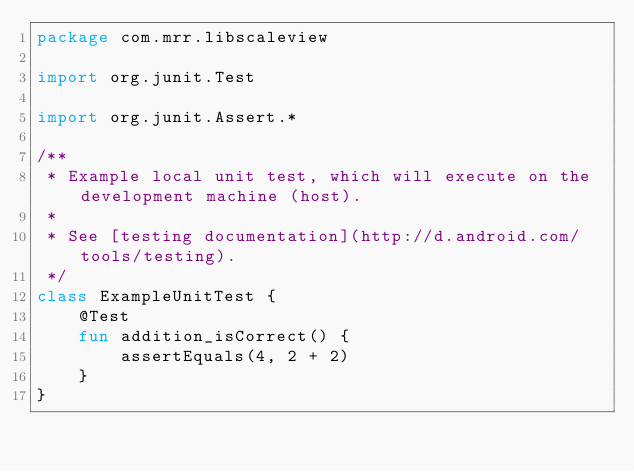Convert code to text. <code><loc_0><loc_0><loc_500><loc_500><_Kotlin_>package com.mrr.libscaleview

import org.junit.Test

import org.junit.Assert.*

/**
 * Example local unit test, which will execute on the development machine (host).
 *
 * See [testing documentation](http://d.android.com/tools/testing).
 */
class ExampleUnitTest {
    @Test
    fun addition_isCorrect() {
        assertEquals(4, 2 + 2)
    }
}</code> 